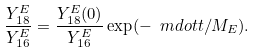Convert formula to latex. <formula><loc_0><loc_0><loc_500><loc_500>\frac { Y _ { 1 8 } ^ { E } } { Y _ { 1 6 } ^ { E } } = \frac { Y _ { 1 8 } ^ { E } ( 0 ) } { Y _ { 1 6 } ^ { E } } \exp ( - \ m d o t t / M _ { E } ) .</formula> 